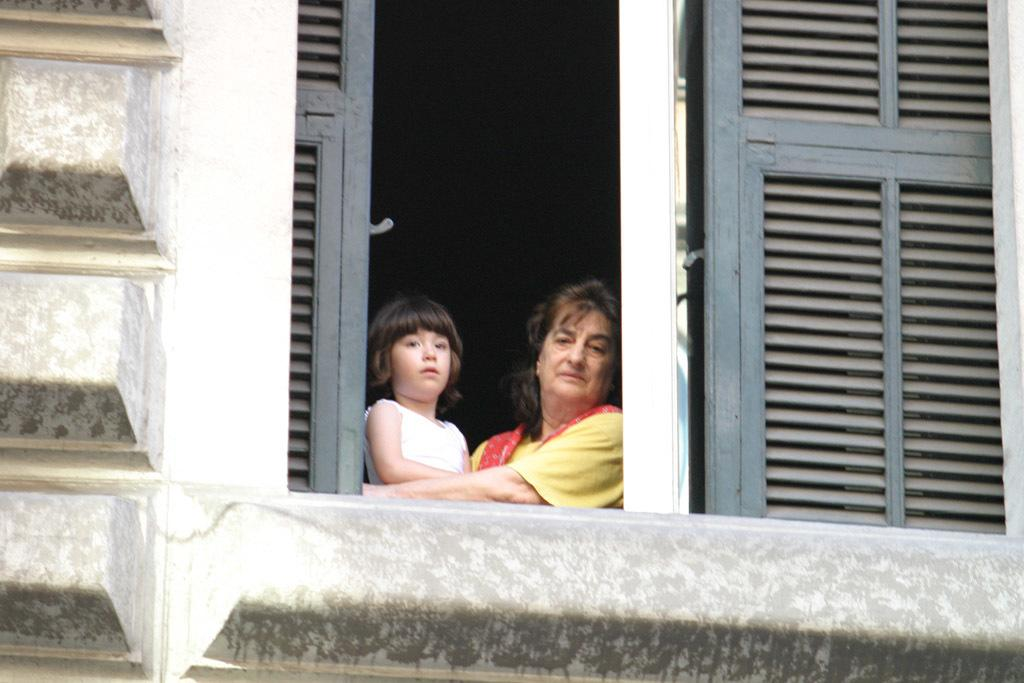Who is present in the image? There is a woman and a girl in the image. What is the woman wearing? The woman is wearing a yellow dress. What is the girl doing in the image? The girl is standing. What can be seen in the background of the image? There is a building in the image. What are the woman and the girl doing together? The woman and the girl are peeping from a window. What language are the woman and the girl speaking in the image? The image does not provide any information about the language being spoken by the woman and the girl. Can you tell me how many skates are visible in the image? There are no skates present in the image. 